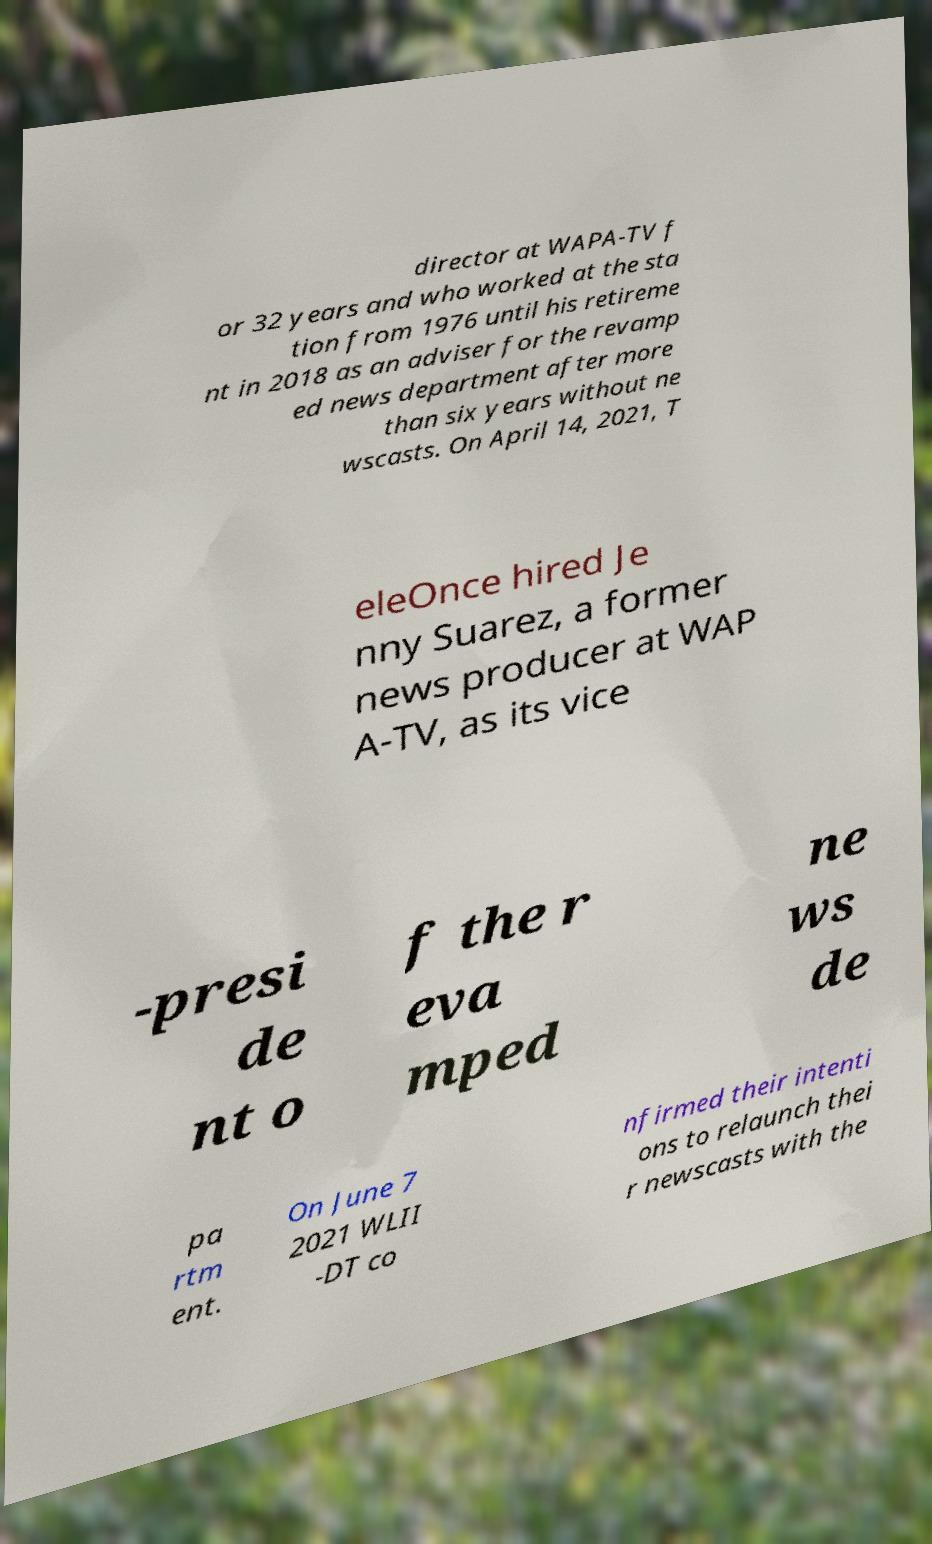Could you extract and type out the text from this image? director at WAPA-TV f or 32 years and who worked at the sta tion from 1976 until his retireme nt in 2018 as an adviser for the revamp ed news department after more than six years without ne wscasts. On April 14, 2021, T eleOnce hired Je nny Suarez, a former news producer at WAP A-TV, as its vice -presi de nt o f the r eva mped ne ws de pa rtm ent. On June 7 2021 WLII -DT co nfirmed their intenti ons to relaunch thei r newscasts with the 